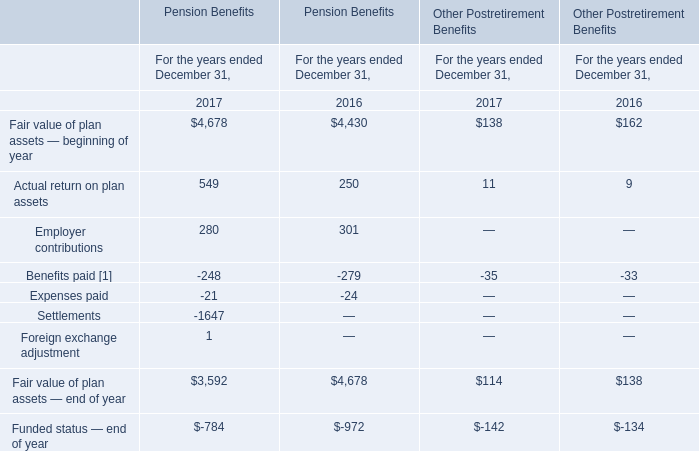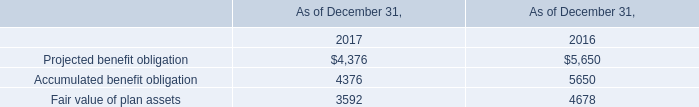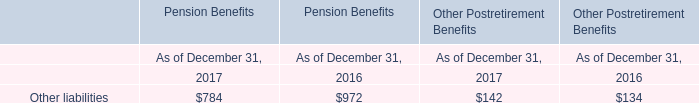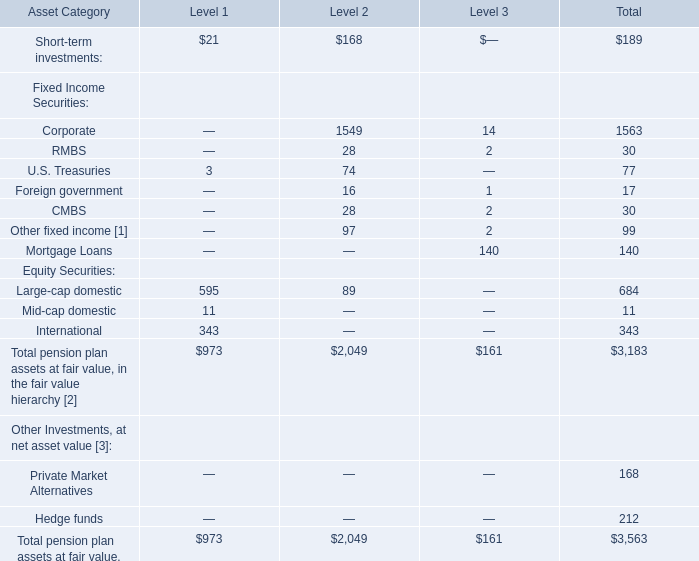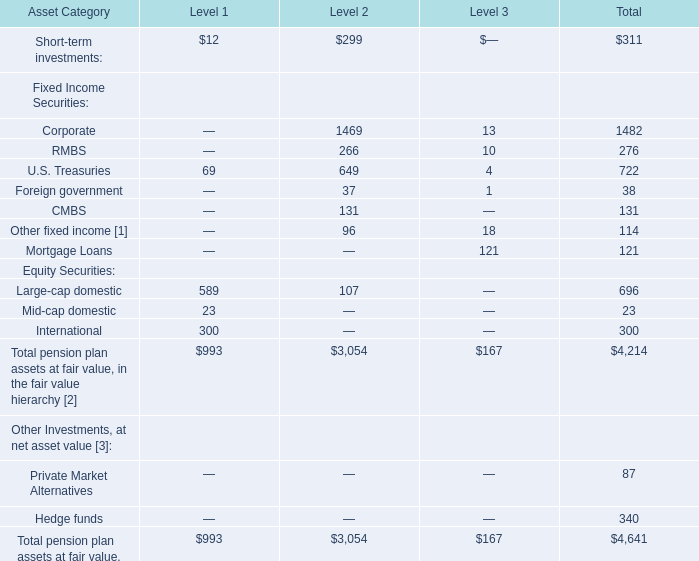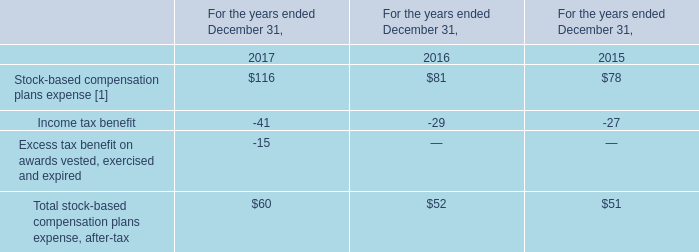What's the total value of all Level 2 that are in the range of 0 and 50 for Fixed Income Securities? 
Computations: ((28 + 16) + 28)
Answer: 72.0. 